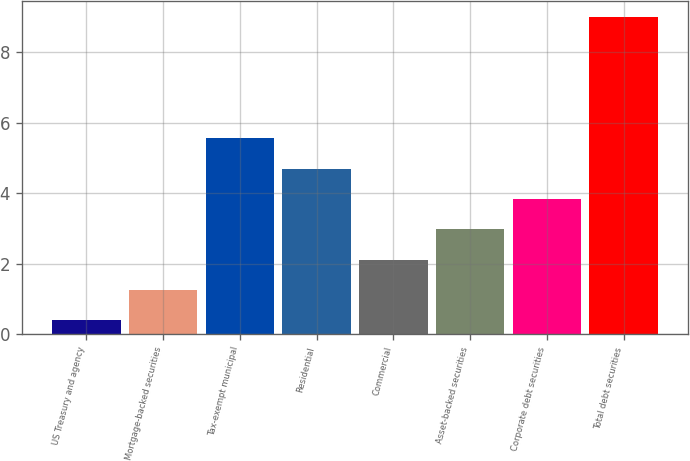Convert chart. <chart><loc_0><loc_0><loc_500><loc_500><bar_chart><fcel>US Treasury and agency<fcel>Mortgage-backed securities<fcel>Tax-exempt municipal<fcel>Residential<fcel>Commercial<fcel>Asset-backed securities<fcel>Corporate debt securities<fcel>Total debt securities<nl><fcel>0.39<fcel>1.25<fcel>5.55<fcel>4.69<fcel>2.11<fcel>2.97<fcel>3.83<fcel>9<nl></chart> 